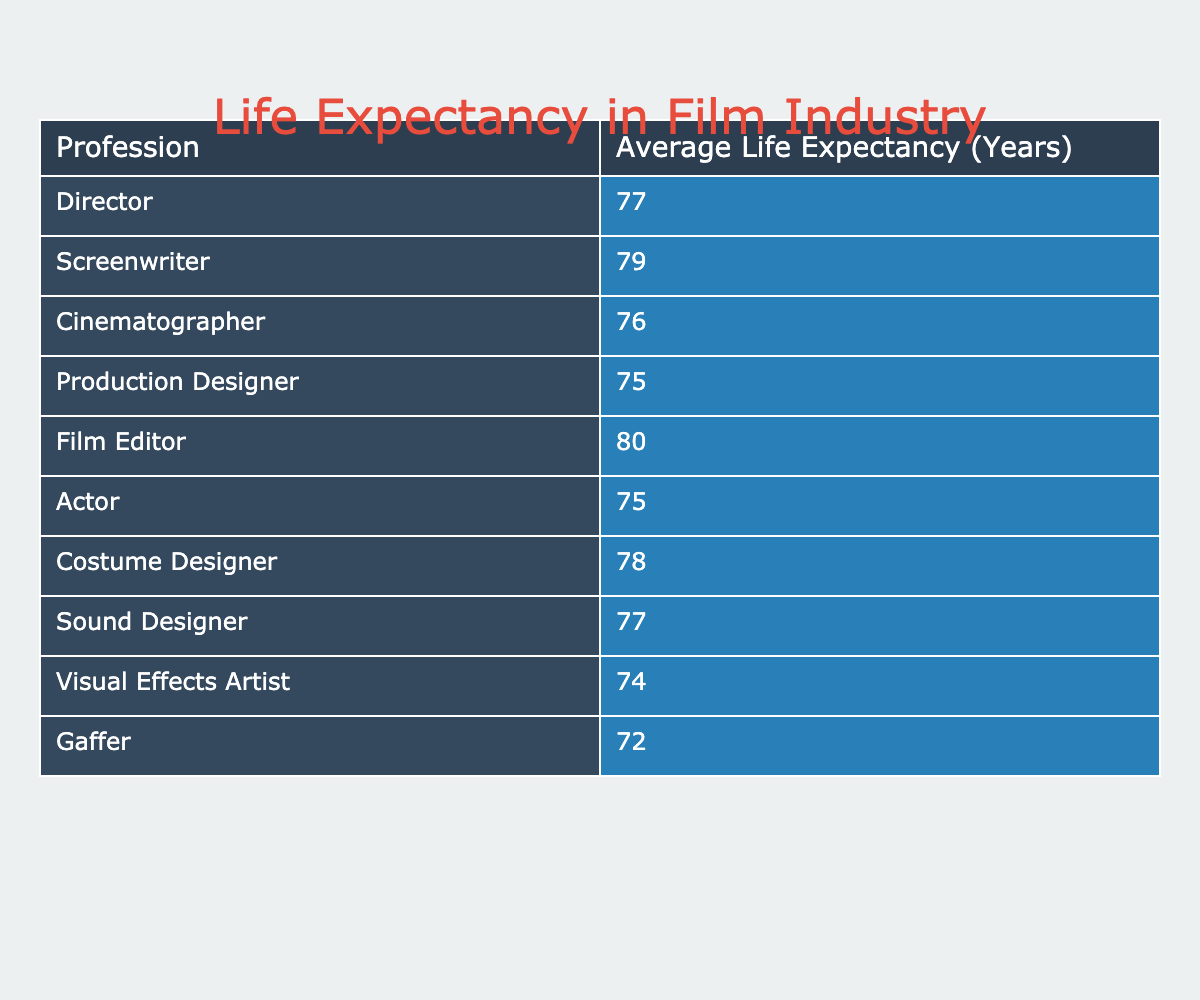What is the average life expectancy for screenwriters? The table lists the average life expectancy of screenwriters as 79 years.
Answer: 79 Which profession has the lowest life expectancy? According to the table, the profession with the lowest life expectancy is Gaffer, with 72 years.
Answer: Gaffer (72 years) What is the life expectancy difference between film editors and visual effects artists? Film editors have an average life expectancy of 80 years while visual effects artists have 74 years. The difference is calculated as 80 - 74 = 6 years.
Answer: 6 years Is the average life expectancy for actors higher than that of cinematographers? Actors have an average life expectancy of 75 years, and cinematographers have 76 years. Since 75 is less than 76, the statement is false.
Answer: No What is the average life expectancy for the professions that have 75 years? The professions with an average life expectancy of 75 years are Actor and Production Designer. There are two such professions, so we calculate the average as (75 + 75) / 2 = 75.
Answer: 75 Which profession has a life expectancy higher than 78 years? From the table, the professions with a life expectancy higher than 78 years are Film Editor (80 years) and Screenwriter (79 years).
Answer: Film Editor and Screenwriter What is the sum of the average life expectancies of all the professions listed? To find the sum, we add the life expectancies: 77 + 79 + 76 + 75 + 80 + 75 + 78 + 77 + 74 + 72 =  762.
Answer: 762 Does the life expectancy for costumers exceed that of gaffers? Costume Designers have a life expectancy of 78 years and Gaffers have 72 years. Since 78 is more than 72, this statement is true.
Answer: Yes Which profession has a life expectancy closest to the average life expectancy of 76 years? By checking the table, both the Cinematographer (76 years) and Sound Designer (77 years) are closest. Cinematographer matches the average while Sound Designer is only 1 year above.
Answer: Cinematographer and Sound Designer 